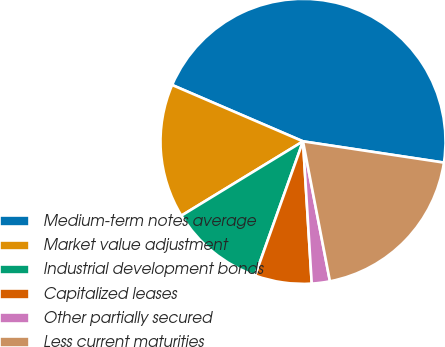Convert chart to OTSL. <chart><loc_0><loc_0><loc_500><loc_500><pie_chart><fcel>Medium-term notes average<fcel>Market value adjustment<fcel>Industrial development bonds<fcel>Capitalized leases<fcel>Other partially secured<fcel>Less current maturities<nl><fcel>45.91%<fcel>15.2%<fcel>10.82%<fcel>6.43%<fcel>2.05%<fcel>19.59%<nl></chart> 